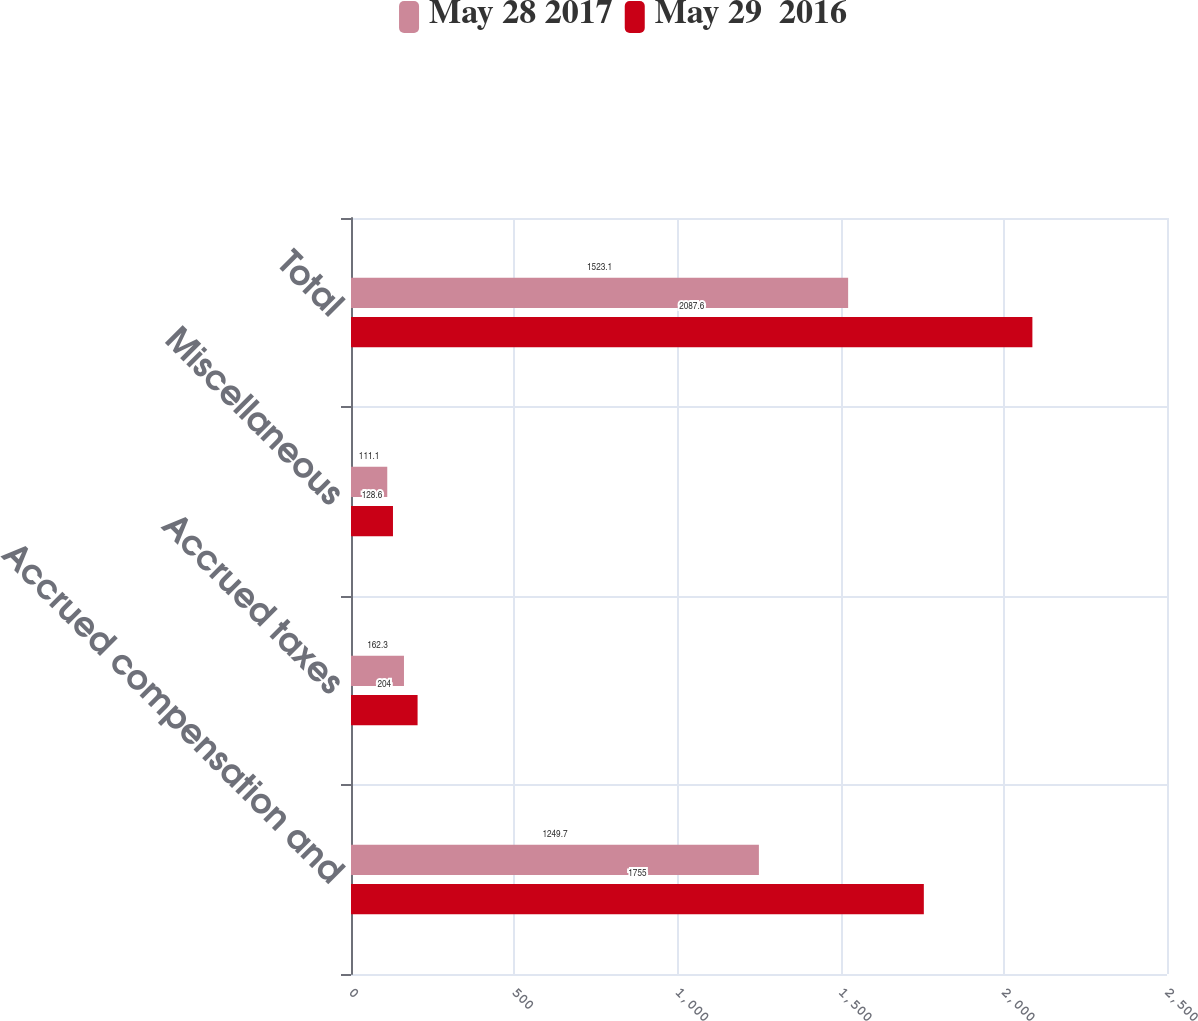<chart> <loc_0><loc_0><loc_500><loc_500><stacked_bar_chart><ecel><fcel>Accrued compensation and<fcel>Accrued taxes<fcel>Miscellaneous<fcel>Total<nl><fcel>May 28 2017<fcel>1249.7<fcel>162.3<fcel>111.1<fcel>1523.1<nl><fcel>May 29  2016<fcel>1755<fcel>204<fcel>128.6<fcel>2087.6<nl></chart> 